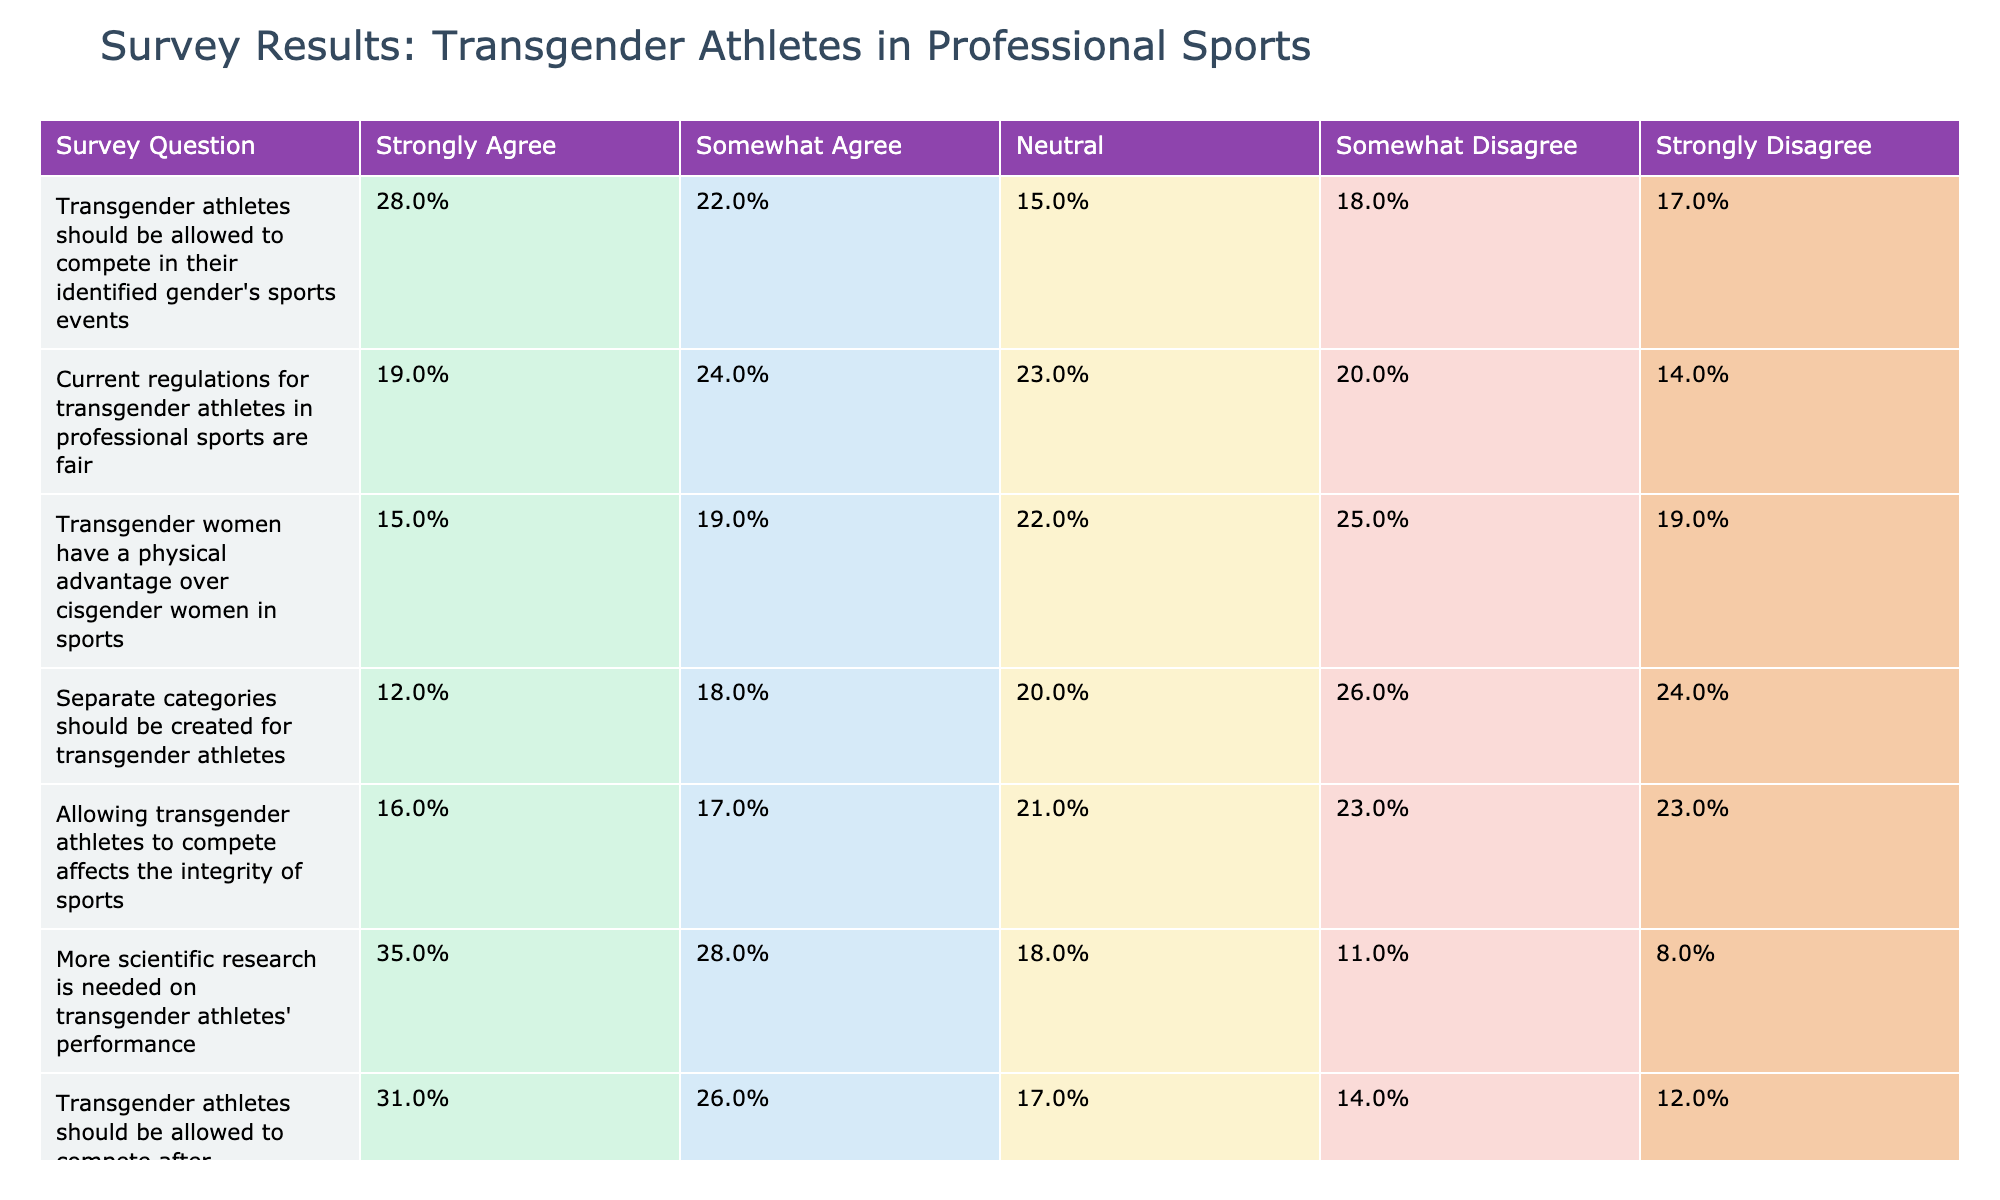What percentage of respondents strongly agree that transgender athletes should compete in their identified gender's sports events? The table shows that 28% of respondents strongly agree with this statement.
Answer: 28% What is the sum of respondents who agree (strongly and somewhat) that current regulations for transgender athletes in professional sports are fair? To find this, add the percentages of "Strongly Agree" (19%) and "Somewhat Agree" (24%): 19% + 24% = 43%.
Answer: 43% Is it true that more respondents strongly disagree than strongly agree with the idea that separate categories should be created for transgender athletes? Strongly disagree percentage is 24%, while strongly agree percentage is 12%, so it is true that more respondents strongly disagree than strongly agree.
Answer: Yes What percentage of respondents either strongly or somewhat agree that transgender women have a physical advantage over cisgender women in sports? Adding the percentages of "Strongly Agree" (15%) and "Somewhat Agree" (19%) gives us a total of 15% + 19% = 34%.
Answer: 34% What is the difference in percentage between respondents who strongly agree that more scientific research is needed on transgender athletes' performance and those who strongly disagree with that statement? The percentage of those who strongly agree is 35% while those who strongly disagree is 8%. So, 35% - 8% = 27%.
Answer: 27% What is the percentage of respondents who are neutral about the idea that allowing transgender athletes to compete affects the integrity of sports? The table indicates that 21% of respondents are neutral regarding this statement.
Answer: 21% What percentage of respondents believe that public opinion should not influence decisions on transgender athletes' participation? The table shows that 27% strongly agree and 23% somewhat agree, totaling 50%.
Answer: 50% What is the average percentage of all respondents who feel that transgender athletes should be allowed to compete after completing hormone therapy? The percentages for "Strongly Agree" (31%), "Somewhat Agree" (26%), "Neutral" (17%), "Somewhat Disagree" (14%), and "Strongly Disagree" (12%) equal 31% + 26% + 17% + 14% + 12% = 100%. The average is 100% / 5 = 20%.
Answer: 20% What is the largest percentage of respondents who hold a single viewpoint across all questions? The largest percentage is 35% who strongly agree that more scientific research is needed on transgender athletes' performance.
Answer: 35% Is there a higher agreement towards the idea that transgender athletes should compete after completing hormone therapy than towards the fairness of current regulations for transgender athletes? Comparing the sum of "Strongly Agree" and "Somewhat Agree" for both statements: 31% + 26% = 57% for hormone therapy, and 19% + 24% = 43% for current regulations, thus it’s true there is a higher agreement for hormone therapy.
Answer: Yes 